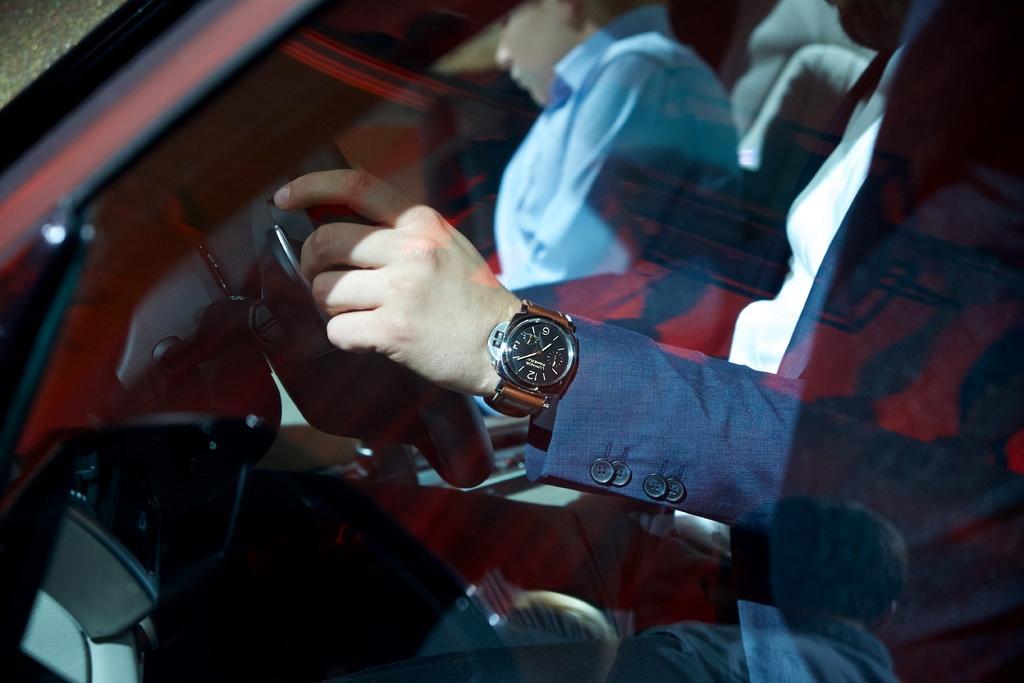Can you describe this image briefly? A person's hand with wrist watch. 